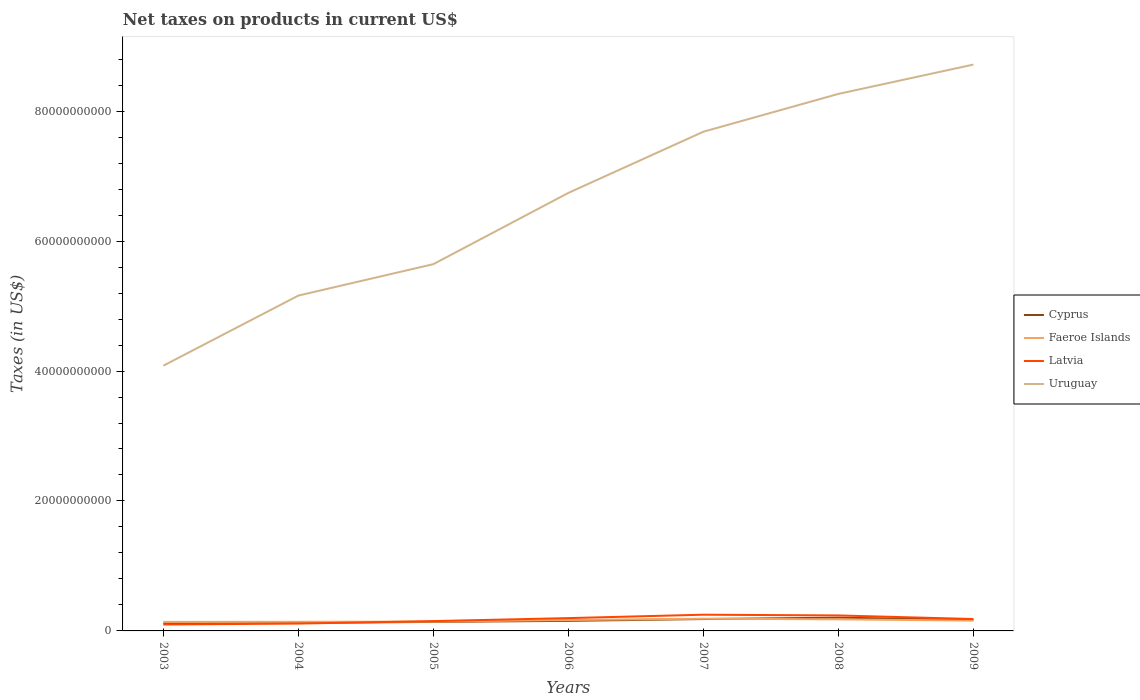Across all years, what is the maximum net taxes on products in Cyprus?
Provide a succinct answer. 1.16e+09. In which year was the net taxes on products in Cyprus maximum?
Give a very brief answer. 2003. What is the total net taxes on products in Latvia in the graph?
Keep it short and to the point. 1.42e+08. What is the difference between the highest and the second highest net taxes on products in Faeroe Islands?
Make the answer very short. 4.94e+08. What is the difference between two consecutive major ticks on the Y-axis?
Ensure brevity in your answer.  2.00e+1. What is the title of the graph?
Make the answer very short. Net taxes on products in current US$. Does "Sweden" appear as one of the legend labels in the graph?
Your answer should be compact. No. What is the label or title of the Y-axis?
Make the answer very short. Taxes (in US$). What is the Taxes (in US$) in Cyprus in 2003?
Make the answer very short. 1.16e+09. What is the Taxes (in US$) in Faeroe Islands in 2003?
Give a very brief answer. 1.39e+09. What is the Taxes (in US$) of Latvia in 2003?
Your response must be concise. 9.88e+08. What is the Taxes (in US$) of Uruguay in 2003?
Provide a short and direct response. 4.08e+1. What is the Taxes (in US$) of Cyprus in 2004?
Provide a short and direct response. 1.25e+09. What is the Taxes (in US$) in Faeroe Islands in 2004?
Your response must be concise. 1.40e+09. What is the Taxes (in US$) of Latvia in 2004?
Give a very brief answer. 1.13e+09. What is the Taxes (in US$) in Uruguay in 2004?
Offer a terse response. 5.16e+1. What is the Taxes (in US$) of Cyprus in 2005?
Keep it short and to the point. 1.39e+09. What is the Taxes (in US$) in Faeroe Islands in 2005?
Offer a terse response. 1.44e+09. What is the Taxes (in US$) in Latvia in 2005?
Ensure brevity in your answer.  1.51e+09. What is the Taxes (in US$) of Uruguay in 2005?
Ensure brevity in your answer.  5.64e+1. What is the Taxes (in US$) of Cyprus in 2006?
Keep it short and to the point. 1.55e+09. What is the Taxes (in US$) in Faeroe Islands in 2006?
Provide a short and direct response. 1.68e+09. What is the Taxes (in US$) of Latvia in 2006?
Ensure brevity in your answer.  1.97e+09. What is the Taxes (in US$) in Uruguay in 2006?
Keep it short and to the point. 6.74e+1. What is the Taxes (in US$) of Cyprus in 2007?
Offer a very short reply. 1.83e+09. What is the Taxes (in US$) in Faeroe Islands in 2007?
Provide a short and direct response. 1.88e+09. What is the Taxes (in US$) of Latvia in 2007?
Keep it short and to the point. 2.50e+09. What is the Taxes (in US$) in Uruguay in 2007?
Keep it short and to the point. 7.68e+1. What is the Taxes (in US$) in Cyprus in 2008?
Your response must be concise. 2.04e+09. What is the Taxes (in US$) in Faeroe Islands in 2008?
Keep it short and to the point. 1.78e+09. What is the Taxes (in US$) of Latvia in 2008?
Your answer should be compact. 2.38e+09. What is the Taxes (in US$) of Uruguay in 2008?
Offer a very short reply. 8.27e+1. What is the Taxes (in US$) of Cyprus in 2009?
Provide a succinct answer. 1.70e+09. What is the Taxes (in US$) in Faeroe Islands in 2009?
Provide a succinct answer. 1.58e+09. What is the Taxes (in US$) of Latvia in 2009?
Your answer should be compact. 1.83e+09. What is the Taxes (in US$) in Uruguay in 2009?
Provide a short and direct response. 8.72e+1. Across all years, what is the maximum Taxes (in US$) of Cyprus?
Your answer should be very brief. 2.04e+09. Across all years, what is the maximum Taxes (in US$) of Faeroe Islands?
Your response must be concise. 1.88e+09. Across all years, what is the maximum Taxes (in US$) in Latvia?
Your answer should be very brief. 2.50e+09. Across all years, what is the maximum Taxes (in US$) in Uruguay?
Your response must be concise. 8.72e+1. Across all years, what is the minimum Taxes (in US$) of Cyprus?
Your answer should be compact. 1.16e+09. Across all years, what is the minimum Taxes (in US$) of Faeroe Islands?
Provide a short and direct response. 1.39e+09. Across all years, what is the minimum Taxes (in US$) of Latvia?
Ensure brevity in your answer.  9.88e+08. Across all years, what is the minimum Taxes (in US$) in Uruguay?
Offer a terse response. 4.08e+1. What is the total Taxes (in US$) of Cyprus in the graph?
Your answer should be very brief. 1.09e+1. What is the total Taxes (in US$) in Faeroe Islands in the graph?
Make the answer very short. 1.12e+1. What is the total Taxes (in US$) in Latvia in the graph?
Provide a short and direct response. 1.23e+1. What is the total Taxes (in US$) in Uruguay in the graph?
Keep it short and to the point. 4.63e+11. What is the difference between the Taxes (in US$) of Cyprus in 2003 and that in 2004?
Offer a very short reply. -8.43e+07. What is the difference between the Taxes (in US$) of Faeroe Islands in 2003 and that in 2004?
Keep it short and to the point. -1.40e+07. What is the difference between the Taxes (in US$) in Latvia in 2003 and that in 2004?
Provide a short and direct response. -1.44e+08. What is the difference between the Taxes (in US$) in Uruguay in 2003 and that in 2004?
Your answer should be compact. -1.08e+1. What is the difference between the Taxes (in US$) in Cyprus in 2003 and that in 2005?
Give a very brief answer. -2.24e+08. What is the difference between the Taxes (in US$) in Faeroe Islands in 2003 and that in 2005?
Ensure brevity in your answer.  -4.80e+07. What is the difference between the Taxes (in US$) of Latvia in 2003 and that in 2005?
Ensure brevity in your answer.  -5.25e+08. What is the difference between the Taxes (in US$) in Uruguay in 2003 and that in 2005?
Ensure brevity in your answer.  -1.56e+1. What is the difference between the Taxes (in US$) of Cyprus in 2003 and that in 2006?
Provide a succinct answer. -3.88e+08. What is the difference between the Taxes (in US$) in Faeroe Islands in 2003 and that in 2006?
Your answer should be very brief. -2.95e+08. What is the difference between the Taxes (in US$) of Latvia in 2003 and that in 2006?
Give a very brief answer. -9.83e+08. What is the difference between the Taxes (in US$) of Uruguay in 2003 and that in 2006?
Your answer should be very brief. -2.66e+1. What is the difference between the Taxes (in US$) of Cyprus in 2003 and that in 2007?
Make the answer very short. -6.66e+08. What is the difference between the Taxes (in US$) in Faeroe Islands in 2003 and that in 2007?
Ensure brevity in your answer.  -4.94e+08. What is the difference between the Taxes (in US$) of Latvia in 2003 and that in 2007?
Ensure brevity in your answer.  -1.51e+09. What is the difference between the Taxes (in US$) in Uruguay in 2003 and that in 2007?
Give a very brief answer. -3.60e+1. What is the difference between the Taxes (in US$) in Cyprus in 2003 and that in 2008?
Provide a short and direct response. -8.80e+08. What is the difference between the Taxes (in US$) of Faeroe Islands in 2003 and that in 2008?
Ensure brevity in your answer.  -3.95e+08. What is the difference between the Taxes (in US$) of Latvia in 2003 and that in 2008?
Make the answer very short. -1.39e+09. What is the difference between the Taxes (in US$) in Uruguay in 2003 and that in 2008?
Provide a succinct answer. -4.18e+1. What is the difference between the Taxes (in US$) in Cyprus in 2003 and that in 2009?
Your answer should be very brief. -5.38e+08. What is the difference between the Taxes (in US$) of Faeroe Islands in 2003 and that in 2009?
Make the answer very short. -1.97e+08. What is the difference between the Taxes (in US$) of Latvia in 2003 and that in 2009?
Make the answer very short. -8.41e+08. What is the difference between the Taxes (in US$) of Uruguay in 2003 and that in 2009?
Your response must be concise. -4.63e+1. What is the difference between the Taxes (in US$) of Cyprus in 2004 and that in 2005?
Ensure brevity in your answer.  -1.40e+08. What is the difference between the Taxes (in US$) of Faeroe Islands in 2004 and that in 2005?
Keep it short and to the point. -3.40e+07. What is the difference between the Taxes (in US$) in Latvia in 2004 and that in 2005?
Your response must be concise. -3.81e+08. What is the difference between the Taxes (in US$) in Uruguay in 2004 and that in 2005?
Give a very brief answer. -4.84e+09. What is the difference between the Taxes (in US$) in Cyprus in 2004 and that in 2006?
Give a very brief answer. -3.03e+08. What is the difference between the Taxes (in US$) of Faeroe Islands in 2004 and that in 2006?
Provide a succinct answer. -2.81e+08. What is the difference between the Taxes (in US$) in Latvia in 2004 and that in 2006?
Provide a short and direct response. -8.39e+08. What is the difference between the Taxes (in US$) of Uruguay in 2004 and that in 2006?
Ensure brevity in your answer.  -1.58e+1. What is the difference between the Taxes (in US$) of Cyprus in 2004 and that in 2007?
Make the answer very short. -5.82e+08. What is the difference between the Taxes (in US$) in Faeroe Islands in 2004 and that in 2007?
Make the answer very short. -4.80e+08. What is the difference between the Taxes (in US$) in Latvia in 2004 and that in 2007?
Your answer should be compact. -1.36e+09. What is the difference between the Taxes (in US$) in Uruguay in 2004 and that in 2007?
Your answer should be compact. -2.52e+1. What is the difference between the Taxes (in US$) in Cyprus in 2004 and that in 2008?
Keep it short and to the point. -7.96e+08. What is the difference between the Taxes (in US$) in Faeroe Islands in 2004 and that in 2008?
Your answer should be compact. -3.81e+08. What is the difference between the Taxes (in US$) of Latvia in 2004 and that in 2008?
Offer a very short reply. -1.25e+09. What is the difference between the Taxes (in US$) of Uruguay in 2004 and that in 2008?
Your response must be concise. -3.10e+1. What is the difference between the Taxes (in US$) in Cyprus in 2004 and that in 2009?
Ensure brevity in your answer.  -4.54e+08. What is the difference between the Taxes (in US$) in Faeroe Islands in 2004 and that in 2009?
Ensure brevity in your answer.  -1.83e+08. What is the difference between the Taxes (in US$) of Latvia in 2004 and that in 2009?
Offer a very short reply. -6.97e+08. What is the difference between the Taxes (in US$) in Uruguay in 2004 and that in 2009?
Your answer should be compact. -3.56e+1. What is the difference between the Taxes (in US$) in Cyprus in 2005 and that in 2006?
Offer a terse response. -1.64e+08. What is the difference between the Taxes (in US$) of Faeroe Islands in 2005 and that in 2006?
Provide a short and direct response. -2.47e+08. What is the difference between the Taxes (in US$) of Latvia in 2005 and that in 2006?
Provide a short and direct response. -4.58e+08. What is the difference between the Taxes (in US$) of Uruguay in 2005 and that in 2006?
Ensure brevity in your answer.  -1.10e+1. What is the difference between the Taxes (in US$) of Cyprus in 2005 and that in 2007?
Keep it short and to the point. -4.42e+08. What is the difference between the Taxes (in US$) in Faeroe Islands in 2005 and that in 2007?
Your answer should be very brief. -4.46e+08. What is the difference between the Taxes (in US$) of Latvia in 2005 and that in 2007?
Provide a short and direct response. -9.83e+08. What is the difference between the Taxes (in US$) in Uruguay in 2005 and that in 2007?
Offer a terse response. -2.04e+1. What is the difference between the Taxes (in US$) of Cyprus in 2005 and that in 2008?
Ensure brevity in your answer.  -6.56e+08. What is the difference between the Taxes (in US$) in Faeroe Islands in 2005 and that in 2008?
Provide a succinct answer. -3.47e+08. What is the difference between the Taxes (in US$) of Latvia in 2005 and that in 2008?
Provide a succinct answer. -8.70e+08. What is the difference between the Taxes (in US$) of Uruguay in 2005 and that in 2008?
Provide a short and direct response. -2.62e+1. What is the difference between the Taxes (in US$) in Cyprus in 2005 and that in 2009?
Give a very brief answer. -3.14e+08. What is the difference between the Taxes (in US$) in Faeroe Islands in 2005 and that in 2009?
Your answer should be compact. -1.49e+08. What is the difference between the Taxes (in US$) of Latvia in 2005 and that in 2009?
Your answer should be compact. -3.16e+08. What is the difference between the Taxes (in US$) of Uruguay in 2005 and that in 2009?
Provide a short and direct response. -3.07e+1. What is the difference between the Taxes (in US$) of Cyprus in 2006 and that in 2007?
Your answer should be very brief. -2.79e+08. What is the difference between the Taxes (in US$) of Faeroe Islands in 2006 and that in 2007?
Your response must be concise. -1.99e+08. What is the difference between the Taxes (in US$) in Latvia in 2006 and that in 2007?
Offer a terse response. -5.24e+08. What is the difference between the Taxes (in US$) of Uruguay in 2006 and that in 2007?
Provide a short and direct response. -9.42e+09. What is the difference between the Taxes (in US$) in Cyprus in 2006 and that in 2008?
Your response must be concise. -4.92e+08. What is the difference between the Taxes (in US$) in Faeroe Islands in 2006 and that in 2008?
Ensure brevity in your answer.  -1.00e+08. What is the difference between the Taxes (in US$) of Latvia in 2006 and that in 2008?
Provide a short and direct response. -4.11e+08. What is the difference between the Taxes (in US$) in Uruguay in 2006 and that in 2008?
Keep it short and to the point. -1.52e+1. What is the difference between the Taxes (in US$) in Cyprus in 2006 and that in 2009?
Keep it short and to the point. -1.51e+08. What is the difference between the Taxes (in US$) of Faeroe Islands in 2006 and that in 2009?
Offer a terse response. 9.80e+07. What is the difference between the Taxes (in US$) of Latvia in 2006 and that in 2009?
Provide a succinct answer. 1.42e+08. What is the difference between the Taxes (in US$) of Uruguay in 2006 and that in 2009?
Offer a terse response. -1.97e+1. What is the difference between the Taxes (in US$) of Cyprus in 2007 and that in 2008?
Provide a succinct answer. -2.14e+08. What is the difference between the Taxes (in US$) of Faeroe Islands in 2007 and that in 2008?
Make the answer very short. 9.90e+07. What is the difference between the Taxes (in US$) of Latvia in 2007 and that in 2008?
Make the answer very short. 1.13e+08. What is the difference between the Taxes (in US$) of Uruguay in 2007 and that in 2008?
Ensure brevity in your answer.  -5.82e+09. What is the difference between the Taxes (in US$) in Cyprus in 2007 and that in 2009?
Your response must be concise. 1.28e+08. What is the difference between the Taxes (in US$) in Faeroe Islands in 2007 and that in 2009?
Provide a short and direct response. 2.97e+08. What is the difference between the Taxes (in US$) of Latvia in 2007 and that in 2009?
Offer a terse response. 6.66e+08. What is the difference between the Taxes (in US$) in Uruguay in 2007 and that in 2009?
Provide a short and direct response. -1.03e+1. What is the difference between the Taxes (in US$) of Cyprus in 2008 and that in 2009?
Provide a short and direct response. 3.42e+08. What is the difference between the Taxes (in US$) in Faeroe Islands in 2008 and that in 2009?
Your answer should be compact. 1.98e+08. What is the difference between the Taxes (in US$) in Latvia in 2008 and that in 2009?
Your response must be concise. 5.53e+08. What is the difference between the Taxes (in US$) in Uruguay in 2008 and that in 2009?
Keep it short and to the point. -4.51e+09. What is the difference between the Taxes (in US$) in Cyprus in 2003 and the Taxes (in US$) in Faeroe Islands in 2004?
Offer a very short reply. -2.40e+08. What is the difference between the Taxes (in US$) in Cyprus in 2003 and the Taxes (in US$) in Latvia in 2004?
Give a very brief answer. 3.05e+07. What is the difference between the Taxes (in US$) of Cyprus in 2003 and the Taxes (in US$) of Uruguay in 2004?
Provide a short and direct response. -5.04e+1. What is the difference between the Taxes (in US$) of Faeroe Islands in 2003 and the Taxes (in US$) of Latvia in 2004?
Offer a terse response. 2.56e+08. What is the difference between the Taxes (in US$) in Faeroe Islands in 2003 and the Taxes (in US$) in Uruguay in 2004?
Keep it short and to the point. -5.02e+1. What is the difference between the Taxes (in US$) in Latvia in 2003 and the Taxes (in US$) in Uruguay in 2004?
Provide a short and direct response. -5.06e+1. What is the difference between the Taxes (in US$) in Cyprus in 2003 and the Taxes (in US$) in Faeroe Islands in 2005?
Your answer should be very brief. -2.74e+08. What is the difference between the Taxes (in US$) of Cyprus in 2003 and the Taxes (in US$) of Latvia in 2005?
Ensure brevity in your answer.  -3.51e+08. What is the difference between the Taxes (in US$) of Cyprus in 2003 and the Taxes (in US$) of Uruguay in 2005?
Keep it short and to the point. -5.53e+1. What is the difference between the Taxes (in US$) in Faeroe Islands in 2003 and the Taxes (in US$) in Latvia in 2005?
Make the answer very short. -1.25e+08. What is the difference between the Taxes (in US$) of Faeroe Islands in 2003 and the Taxes (in US$) of Uruguay in 2005?
Offer a very short reply. -5.51e+1. What is the difference between the Taxes (in US$) of Latvia in 2003 and the Taxes (in US$) of Uruguay in 2005?
Give a very brief answer. -5.55e+1. What is the difference between the Taxes (in US$) in Cyprus in 2003 and the Taxes (in US$) in Faeroe Islands in 2006?
Provide a short and direct response. -5.21e+08. What is the difference between the Taxes (in US$) of Cyprus in 2003 and the Taxes (in US$) of Latvia in 2006?
Make the answer very short. -8.09e+08. What is the difference between the Taxes (in US$) in Cyprus in 2003 and the Taxes (in US$) in Uruguay in 2006?
Your answer should be compact. -6.63e+1. What is the difference between the Taxes (in US$) in Faeroe Islands in 2003 and the Taxes (in US$) in Latvia in 2006?
Provide a short and direct response. -5.83e+08. What is the difference between the Taxes (in US$) in Faeroe Islands in 2003 and the Taxes (in US$) in Uruguay in 2006?
Keep it short and to the point. -6.60e+1. What is the difference between the Taxes (in US$) in Latvia in 2003 and the Taxes (in US$) in Uruguay in 2006?
Provide a short and direct response. -6.64e+1. What is the difference between the Taxes (in US$) in Cyprus in 2003 and the Taxes (in US$) in Faeroe Islands in 2007?
Ensure brevity in your answer.  -7.20e+08. What is the difference between the Taxes (in US$) in Cyprus in 2003 and the Taxes (in US$) in Latvia in 2007?
Keep it short and to the point. -1.33e+09. What is the difference between the Taxes (in US$) in Cyprus in 2003 and the Taxes (in US$) in Uruguay in 2007?
Ensure brevity in your answer.  -7.57e+1. What is the difference between the Taxes (in US$) of Faeroe Islands in 2003 and the Taxes (in US$) of Latvia in 2007?
Ensure brevity in your answer.  -1.11e+09. What is the difference between the Taxes (in US$) of Faeroe Islands in 2003 and the Taxes (in US$) of Uruguay in 2007?
Make the answer very short. -7.54e+1. What is the difference between the Taxes (in US$) in Latvia in 2003 and the Taxes (in US$) in Uruguay in 2007?
Make the answer very short. -7.58e+1. What is the difference between the Taxes (in US$) in Cyprus in 2003 and the Taxes (in US$) in Faeroe Islands in 2008?
Keep it short and to the point. -6.21e+08. What is the difference between the Taxes (in US$) of Cyprus in 2003 and the Taxes (in US$) of Latvia in 2008?
Ensure brevity in your answer.  -1.22e+09. What is the difference between the Taxes (in US$) in Cyprus in 2003 and the Taxes (in US$) in Uruguay in 2008?
Ensure brevity in your answer.  -8.15e+1. What is the difference between the Taxes (in US$) in Faeroe Islands in 2003 and the Taxes (in US$) in Latvia in 2008?
Ensure brevity in your answer.  -9.94e+08. What is the difference between the Taxes (in US$) in Faeroe Islands in 2003 and the Taxes (in US$) in Uruguay in 2008?
Provide a succinct answer. -8.13e+1. What is the difference between the Taxes (in US$) in Latvia in 2003 and the Taxes (in US$) in Uruguay in 2008?
Give a very brief answer. -8.17e+1. What is the difference between the Taxes (in US$) of Cyprus in 2003 and the Taxes (in US$) of Faeroe Islands in 2009?
Your answer should be very brief. -4.23e+08. What is the difference between the Taxes (in US$) in Cyprus in 2003 and the Taxes (in US$) in Latvia in 2009?
Give a very brief answer. -6.67e+08. What is the difference between the Taxes (in US$) in Cyprus in 2003 and the Taxes (in US$) in Uruguay in 2009?
Ensure brevity in your answer.  -8.60e+1. What is the difference between the Taxes (in US$) in Faeroe Islands in 2003 and the Taxes (in US$) in Latvia in 2009?
Offer a terse response. -4.41e+08. What is the difference between the Taxes (in US$) of Faeroe Islands in 2003 and the Taxes (in US$) of Uruguay in 2009?
Your response must be concise. -8.58e+1. What is the difference between the Taxes (in US$) in Latvia in 2003 and the Taxes (in US$) in Uruguay in 2009?
Provide a succinct answer. -8.62e+1. What is the difference between the Taxes (in US$) in Cyprus in 2004 and the Taxes (in US$) in Faeroe Islands in 2005?
Provide a succinct answer. -1.90e+08. What is the difference between the Taxes (in US$) of Cyprus in 2004 and the Taxes (in US$) of Latvia in 2005?
Your answer should be compact. -2.66e+08. What is the difference between the Taxes (in US$) of Cyprus in 2004 and the Taxes (in US$) of Uruguay in 2005?
Provide a short and direct response. -5.52e+1. What is the difference between the Taxes (in US$) of Faeroe Islands in 2004 and the Taxes (in US$) of Latvia in 2005?
Provide a succinct answer. -1.11e+08. What is the difference between the Taxes (in US$) of Faeroe Islands in 2004 and the Taxes (in US$) of Uruguay in 2005?
Give a very brief answer. -5.50e+1. What is the difference between the Taxes (in US$) in Latvia in 2004 and the Taxes (in US$) in Uruguay in 2005?
Your answer should be very brief. -5.53e+1. What is the difference between the Taxes (in US$) in Cyprus in 2004 and the Taxes (in US$) in Faeroe Islands in 2006?
Your answer should be compact. -4.37e+08. What is the difference between the Taxes (in US$) in Cyprus in 2004 and the Taxes (in US$) in Latvia in 2006?
Give a very brief answer. -7.25e+08. What is the difference between the Taxes (in US$) of Cyprus in 2004 and the Taxes (in US$) of Uruguay in 2006?
Offer a terse response. -6.62e+1. What is the difference between the Taxes (in US$) of Faeroe Islands in 2004 and the Taxes (in US$) of Latvia in 2006?
Give a very brief answer. -5.69e+08. What is the difference between the Taxes (in US$) of Faeroe Islands in 2004 and the Taxes (in US$) of Uruguay in 2006?
Ensure brevity in your answer.  -6.60e+1. What is the difference between the Taxes (in US$) in Latvia in 2004 and the Taxes (in US$) in Uruguay in 2006?
Provide a short and direct response. -6.63e+1. What is the difference between the Taxes (in US$) of Cyprus in 2004 and the Taxes (in US$) of Faeroe Islands in 2007?
Offer a terse response. -6.36e+08. What is the difference between the Taxes (in US$) in Cyprus in 2004 and the Taxes (in US$) in Latvia in 2007?
Your answer should be very brief. -1.25e+09. What is the difference between the Taxes (in US$) of Cyprus in 2004 and the Taxes (in US$) of Uruguay in 2007?
Provide a succinct answer. -7.56e+1. What is the difference between the Taxes (in US$) in Faeroe Islands in 2004 and the Taxes (in US$) in Latvia in 2007?
Your answer should be compact. -1.09e+09. What is the difference between the Taxes (in US$) of Faeroe Islands in 2004 and the Taxes (in US$) of Uruguay in 2007?
Ensure brevity in your answer.  -7.54e+1. What is the difference between the Taxes (in US$) in Latvia in 2004 and the Taxes (in US$) in Uruguay in 2007?
Your answer should be very brief. -7.57e+1. What is the difference between the Taxes (in US$) of Cyprus in 2004 and the Taxes (in US$) of Faeroe Islands in 2008?
Offer a terse response. -5.37e+08. What is the difference between the Taxes (in US$) of Cyprus in 2004 and the Taxes (in US$) of Latvia in 2008?
Make the answer very short. -1.14e+09. What is the difference between the Taxes (in US$) in Cyprus in 2004 and the Taxes (in US$) in Uruguay in 2008?
Offer a very short reply. -8.14e+1. What is the difference between the Taxes (in US$) in Faeroe Islands in 2004 and the Taxes (in US$) in Latvia in 2008?
Provide a short and direct response. -9.80e+08. What is the difference between the Taxes (in US$) of Faeroe Islands in 2004 and the Taxes (in US$) of Uruguay in 2008?
Provide a succinct answer. -8.12e+1. What is the difference between the Taxes (in US$) of Latvia in 2004 and the Taxes (in US$) of Uruguay in 2008?
Your answer should be compact. -8.15e+1. What is the difference between the Taxes (in US$) in Cyprus in 2004 and the Taxes (in US$) in Faeroe Islands in 2009?
Make the answer very short. -3.39e+08. What is the difference between the Taxes (in US$) in Cyprus in 2004 and the Taxes (in US$) in Latvia in 2009?
Keep it short and to the point. -5.83e+08. What is the difference between the Taxes (in US$) in Cyprus in 2004 and the Taxes (in US$) in Uruguay in 2009?
Your response must be concise. -8.59e+1. What is the difference between the Taxes (in US$) in Faeroe Islands in 2004 and the Taxes (in US$) in Latvia in 2009?
Provide a succinct answer. -4.27e+08. What is the difference between the Taxes (in US$) of Faeroe Islands in 2004 and the Taxes (in US$) of Uruguay in 2009?
Provide a short and direct response. -8.58e+1. What is the difference between the Taxes (in US$) in Latvia in 2004 and the Taxes (in US$) in Uruguay in 2009?
Your answer should be very brief. -8.60e+1. What is the difference between the Taxes (in US$) of Cyprus in 2005 and the Taxes (in US$) of Faeroe Islands in 2006?
Your response must be concise. -2.97e+08. What is the difference between the Taxes (in US$) in Cyprus in 2005 and the Taxes (in US$) in Latvia in 2006?
Your answer should be very brief. -5.85e+08. What is the difference between the Taxes (in US$) of Cyprus in 2005 and the Taxes (in US$) of Uruguay in 2006?
Provide a short and direct response. -6.60e+1. What is the difference between the Taxes (in US$) of Faeroe Islands in 2005 and the Taxes (in US$) of Latvia in 2006?
Your response must be concise. -5.35e+08. What is the difference between the Taxes (in US$) of Faeroe Islands in 2005 and the Taxes (in US$) of Uruguay in 2006?
Your answer should be very brief. -6.60e+1. What is the difference between the Taxes (in US$) of Latvia in 2005 and the Taxes (in US$) of Uruguay in 2006?
Your answer should be compact. -6.59e+1. What is the difference between the Taxes (in US$) of Cyprus in 2005 and the Taxes (in US$) of Faeroe Islands in 2007?
Keep it short and to the point. -4.96e+08. What is the difference between the Taxes (in US$) in Cyprus in 2005 and the Taxes (in US$) in Latvia in 2007?
Your response must be concise. -1.11e+09. What is the difference between the Taxes (in US$) in Cyprus in 2005 and the Taxes (in US$) in Uruguay in 2007?
Make the answer very short. -7.54e+1. What is the difference between the Taxes (in US$) in Faeroe Islands in 2005 and the Taxes (in US$) in Latvia in 2007?
Your response must be concise. -1.06e+09. What is the difference between the Taxes (in US$) of Faeroe Islands in 2005 and the Taxes (in US$) of Uruguay in 2007?
Give a very brief answer. -7.54e+1. What is the difference between the Taxes (in US$) of Latvia in 2005 and the Taxes (in US$) of Uruguay in 2007?
Ensure brevity in your answer.  -7.53e+1. What is the difference between the Taxes (in US$) of Cyprus in 2005 and the Taxes (in US$) of Faeroe Islands in 2008?
Offer a terse response. -3.97e+08. What is the difference between the Taxes (in US$) of Cyprus in 2005 and the Taxes (in US$) of Latvia in 2008?
Your answer should be very brief. -9.96e+08. What is the difference between the Taxes (in US$) of Cyprus in 2005 and the Taxes (in US$) of Uruguay in 2008?
Keep it short and to the point. -8.13e+1. What is the difference between the Taxes (in US$) in Faeroe Islands in 2005 and the Taxes (in US$) in Latvia in 2008?
Ensure brevity in your answer.  -9.46e+08. What is the difference between the Taxes (in US$) of Faeroe Islands in 2005 and the Taxes (in US$) of Uruguay in 2008?
Your answer should be very brief. -8.12e+1. What is the difference between the Taxes (in US$) in Latvia in 2005 and the Taxes (in US$) in Uruguay in 2008?
Your answer should be very brief. -8.11e+1. What is the difference between the Taxes (in US$) in Cyprus in 2005 and the Taxes (in US$) in Faeroe Islands in 2009?
Your response must be concise. -1.99e+08. What is the difference between the Taxes (in US$) in Cyprus in 2005 and the Taxes (in US$) in Latvia in 2009?
Keep it short and to the point. -4.43e+08. What is the difference between the Taxes (in US$) in Cyprus in 2005 and the Taxes (in US$) in Uruguay in 2009?
Give a very brief answer. -8.58e+1. What is the difference between the Taxes (in US$) of Faeroe Islands in 2005 and the Taxes (in US$) of Latvia in 2009?
Your answer should be very brief. -3.93e+08. What is the difference between the Taxes (in US$) of Faeroe Islands in 2005 and the Taxes (in US$) of Uruguay in 2009?
Your response must be concise. -8.57e+1. What is the difference between the Taxes (in US$) in Latvia in 2005 and the Taxes (in US$) in Uruguay in 2009?
Provide a short and direct response. -8.57e+1. What is the difference between the Taxes (in US$) of Cyprus in 2006 and the Taxes (in US$) of Faeroe Islands in 2007?
Offer a very short reply. -3.32e+08. What is the difference between the Taxes (in US$) in Cyprus in 2006 and the Taxes (in US$) in Latvia in 2007?
Make the answer very short. -9.46e+08. What is the difference between the Taxes (in US$) of Cyprus in 2006 and the Taxes (in US$) of Uruguay in 2007?
Keep it short and to the point. -7.53e+1. What is the difference between the Taxes (in US$) of Faeroe Islands in 2006 and the Taxes (in US$) of Latvia in 2007?
Make the answer very short. -8.12e+08. What is the difference between the Taxes (in US$) in Faeroe Islands in 2006 and the Taxes (in US$) in Uruguay in 2007?
Keep it short and to the point. -7.52e+1. What is the difference between the Taxes (in US$) of Latvia in 2006 and the Taxes (in US$) of Uruguay in 2007?
Keep it short and to the point. -7.49e+1. What is the difference between the Taxes (in US$) in Cyprus in 2006 and the Taxes (in US$) in Faeroe Islands in 2008?
Ensure brevity in your answer.  -2.33e+08. What is the difference between the Taxes (in US$) in Cyprus in 2006 and the Taxes (in US$) in Latvia in 2008?
Ensure brevity in your answer.  -8.32e+08. What is the difference between the Taxes (in US$) in Cyprus in 2006 and the Taxes (in US$) in Uruguay in 2008?
Offer a terse response. -8.11e+1. What is the difference between the Taxes (in US$) in Faeroe Islands in 2006 and the Taxes (in US$) in Latvia in 2008?
Offer a very short reply. -6.99e+08. What is the difference between the Taxes (in US$) of Faeroe Islands in 2006 and the Taxes (in US$) of Uruguay in 2008?
Ensure brevity in your answer.  -8.10e+1. What is the difference between the Taxes (in US$) of Latvia in 2006 and the Taxes (in US$) of Uruguay in 2008?
Give a very brief answer. -8.07e+1. What is the difference between the Taxes (in US$) of Cyprus in 2006 and the Taxes (in US$) of Faeroe Islands in 2009?
Offer a terse response. -3.54e+07. What is the difference between the Taxes (in US$) of Cyprus in 2006 and the Taxes (in US$) of Latvia in 2009?
Make the answer very short. -2.79e+08. What is the difference between the Taxes (in US$) in Cyprus in 2006 and the Taxes (in US$) in Uruguay in 2009?
Keep it short and to the point. -8.56e+1. What is the difference between the Taxes (in US$) of Faeroe Islands in 2006 and the Taxes (in US$) of Latvia in 2009?
Keep it short and to the point. -1.46e+08. What is the difference between the Taxes (in US$) in Faeroe Islands in 2006 and the Taxes (in US$) in Uruguay in 2009?
Your answer should be compact. -8.55e+1. What is the difference between the Taxes (in US$) of Latvia in 2006 and the Taxes (in US$) of Uruguay in 2009?
Give a very brief answer. -8.52e+1. What is the difference between the Taxes (in US$) in Cyprus in 2007 and the Taxes (in US$) in Faeroe Islands in 2008?
Your response must be concise. 4.54e+07. What is the difference between the Taxes (in US$) in Cyprus in 2007 and the Taxes (in US$) in Latvia in 2008?
Make the answer very short. -5.54e+08. What is the difference between the Taxes (in US$) in Cyprus in 2007 and the Taxes (in US$) in Uruguay in 2008?
Ensure brevity in your answer.  -8.08e+1. What is the difference between the Taxes (in US$) of Faeroe Islands in 2007 and the Taxes (in US$) of Latvia in 2008?
Offer a terse response. -5.00e+08. What is the difference between the Taxes (in US$) in Faeroe Islands in 2007 and the Taxes (in US$) in Uruguay in 2008?
Offer a very short reply. -8.08e+1. What is the difference between the Taxes (in US$) of Latvia in 2007 and the Taxes (in US$) of Uruguay in 2008?
Your answer should be compact. -8.02e+1. What is the difference between the Taxes (in US$) in Cyprus in 2007 and the Taxes (in US$) in Faeroe Islands in 2009?
Make the answer very short. 2.43e+08. What is the difference between the Taxes (in US$) in Cyprus in 2007 and the Taxes (in US$) in Latvia in 2009?
Keep it short and to the point. -5.34e+05. What is the difference between the Taxes (in US$) of Cyprus in 2007 and the Taxes (in US$) of Uruguay in 2009?
Your response must be concise. -8.53e+1. What is the difference between the Taxes (in US$) in Faeroe Islands in 2007 and the Taxes (in US$) in Latvia in 2009?
Provide a succinct answer. 5.31e+07. What is the difference between the Taxes (in US$) of Faeroe Islands in 2007 and the Taxes (in US$) of Uruguay in 2009?
Offer a terse response. -8.53e+1. What is the difference between the Taxes (in US$) of Latvia in 2007 and the Taxes (in US$) of Uruguay in 2009?
Keep it short and to the point. -8.47e+1. What is the difference between the Taxes (in US$) in Cyprus in 2008 and the Taxes (in US$) in Faeroe Islands in 2009?
Your answer should be compact. 4.57e+08. What is the difference between the Taxes (in US$) in Cyprus in 2008 and the Taxes (in US$) in Latvia in 2009?
Your answer should be very brief. 2.13e+08. What is the difference between the Taxes (in US$) in Cyprus in 2008 and the Taxes (in US$) in Uruguay in 2009?
Give a very brief answer. -8.51e+1. What is the difference between the Taxes (in US$) in Faeroe Islands in 2008 and the Taxes (in US$) in Latvia in 2009?
Offer a terse response. -4.59e+07. What is the difference between the Taxes (in US$) in Faeroe Islands in 2008 and the Taxes (in US$) in Uruguay in 2009?
Make the answer very short. -8.54e+1. What is the difference between the Taxes (in US$) in Latvia in 2008 and the Taxes (in US$) in Uruguay in 2009?
Make the answer very short. -8.48e+1. What is the average Taxes (in US$) in Cyprus per year?
Give a very brief answer. 1.56e+09. What is the average Taxes (in US$) of Faeroe Islands per year?
Keep it short and to the point. 1.59e+09. What is the average Taxes (in US$) in Latvia per year?
Make the answer very short. 1.76e+09. What is the average Taxes (in US$) of Uruguay per year?
Provide a short and direct response. 6.61e+1. In the year 2003, what is the difference between the Taxes (in US$) of Cyprus and Taxes (in US$) of Faeroe Islands?
Keep it short and to the point. -2.26e+08. In the year 2003, what is the difference between the Taxes (in US$) of Cyprus and Taxes (in US$) of Latvia?
Offer a very short reply. 1.74e+08. In the year 2003, what is the difference between the Taxes (in US$) of Cyprus and Taxes (in US$) of Uruguay?
Your response must be concise. -3.97e+1. In the year 2003, what is the difference between the Taxes (in US$) of Faeroe Islands and Taxes (in US$) of Latvia?
Your response must be concise. 4.00e+08. In the year 2003, what is the difference between the Taxes (in US$) of Faeroe Islands and Taxes (in US$) of Uruguay?
Provide a succinct answer. -3.94e+1. In the year 2003, what is the difference between the Taxes (in US$) of Latvia and Taxes (in US$) of Uruguay?
Provide a succinct answer. -3.98e+1. In the year 2004, what is the difference between the Taxes (in US$) in Cyprus and Taxes (in US$) in Faeroe Islands?
Make the answer very short. -1.56e+08. In the year 2004, what is the difference between the Taxes (in US$) of Cyprus and Taxes (in US$) of Latvia?
Offer a very short reply. 1.15e+08. In the year 2004, what is the difference between the Taxes (in US$) of Cyprus and Taxes (in US$) of Uruguay?
Offer a terse response. -5.04e+1. In the year 2004, what is the difference between the Taxes (in US$) in Faeroe Islands and Taxes (in US$) in Latvia?
Offer a terse response. 2.70e+08. In the year 2004, what is the difference between the Taxes (in US$) in Faeroe Islands and Taxes (in US$) in Uruguay?
Offer a very short reply. -5.02e+1. In the year 2004, what is the difference between the Taxes (in US$) of Latvia and Taxes (in US$) of Uruguay?
Make the answer very short. -5.05e+1. In the year 2005, what is the difference between the Taxes (in US$) of Cyprus and Taxes (in US$) of Faeroe Islands?
Offer a very short reply. -4.99e+07. In the year 2005, what is the difference between the Taxes (in US$) of Cyprus and Taxes (in US$) of Latvia?
Offer a very short reply. -1.26e+08. In the year 2005, what is the difference between the Taxes (in US$) of Cyprus and Taxes (in US$) of Uruguay?
Ensure brevity in your answer.  -5.51e+1. In the year 2005, what is the difference between the Taxes (in US$) in Faeroe Islands and Taxes (in US$) in Latvia?
Your answer should be compact. -7.65e+07. In the year 2005, what is the difference between the Taxes (in US$) of Faeroe Islands and Taxes (in US$) of Uruguay?
Offer a terse response. -5.50e+1. In the year 2005, what is the difference between the Taxes (in US$) in Latvia and Taxes (in US$) in Uruguay?
Offer a terse response. -5.49e+1. In the year 2006, what is the difference between the Taxes (in US$) of Cyprus and Taxes (in US$) of Faeroe Islands?
Provide a short and direct response. -1.33e+08. In the year 2006, what is the difference between the Taxes (in US$) in Cyprus and Taxes (in US$) in Latvia?
Your response must be concise. -4.21e+08. In the year 2006, what is the difference between the Taxes (in US$) of Cyprus and Taxes (in US$) of Uruguay?
Keep it short and to the point. -6.59e+1. In the year 2006, what is the difference between the Taxes (in US$) in Faeroe Islands and Taxes (in US$) in Latvia?
Your answer should be compact. -2.88e+08. In the year 2006, what is the difference between the Taxes (in US$) of Faeroe Islands and Taxes (in US$) of Uruguay?
Make the answer very short. -6.57e+1. In the year 2006, what is the difference between the Taxes (in US$) in Latvia and Taxes (in US$) in Uruguay?
Offer a very short reply. -6.54e+1. In the year 2007, what is the difference between the Taxes (in US$) of Cyprus and Taxes (in US$) of Faeroe Islands?
Your answer should be very brief. -5.36e+07. In the year 2007, what is the difference between the Taxes (in US$) of Cyprus and Taxes (in US$) of Latvia?
Provide a short and direct response. -6.67e+08. In the year 2007, what is the difference between the Taxes (in US$) in Cyprus and Taxes (in US$) in Uruguay?
Offer a terse response. -7.50e+1. In the year 2007, what is the difference between the Taxes (in US$) in Faeroe Islands and Taxes (in US$) in Latvia?
Your response must be concise. -6.13e+08. In the year 2007, what is the difference between the Taxes (in US$) of Faeroe Islands and Taxes (in US$) of Uruguay?
Your answer should be compact. -7.50e+1. In the year 2007, what is the difference between the Taxes (in US$) of Latvia and Taxes (in US$) of Uruguay?
Your answer should be compact. -7.43e+1. In the year 2008, what is the difference between the Taxes (in US$) of Cyprus and Taxes (in US$) of Faeroe Islands?
Ensure brevity in your answer.  2.59e+08. In the year 2008, what is the difference between the Taxes (in US$) of Cyprus and Taxes (in US$) of Latvia?
Keep it short and to the point. -3.40e+08. In the year 2008, what is the difference between the Taxes (in US$) of Cyprus and Taxes (in US$) of Uruguay?
Ensure brevity in your answer.  -8.06e+1. In the year 2008, what is the difference between the Taxes (in US$) of Faeroe Islands and Taxes (in US$) of Latvia?
Ensure brevity in your answer.  -5.99e+08. In the year 2008, what is the difference between the Taxes (in US$) of Faeroe Islands and Taxes (in US$) of Uruguay?
Offer a very short reply. -8.09e+1. In the year 2008, what is the difference between the Taxes (in US$) of Latvia and Taxes (in US$) of Uruguay?
Your answer should be compact. -8.03e+1. In the year 2009, what is the difference between the Taxes (in US$) of Cyprus and Taxes (in US$) of Faeroe Islands?
Ensure brevity in your answer.  1.15e+08. In the year 2009, what is the difference between the Taxes (in US$) in Cyprus and Taxes (in US$) in Latvia?
Your answer should be very brief. -1.29e+08. In the year 2009, what is the difference between the Taxes (in US$) in Cyprus and Taxes (in US$) in Uruguay?
Ensure brevity in your answer.  -8.55e+1. In the year 2009, what is the difference between the Taxes (in US$) of Faeroe Islands and Taxes (in US$) of Latvia?
Offer a terse response. -2.44e+08. In the year 2009, what is the difference between the Taxes (in US$) in Faeroe Islands and Taxes (in US$) in Uruguay?
Your response must be concise. -8.56e+1. In the year 2009, what is the difference between the Taxes (in US$) in Latvia and Taxes (in US$) in Uruguay?
Offer a very short reply. -8.53e+1. What is the ratio of the Taxes (in US$) in Cyprus in 2003 to that in 2004?
Your answer should be very brief. 0.93. What is the ratio of the Taxes (in US$) of Latvia in 2003 to that in 2004?
Make the answer very short. 0.87. What is the ratio of the Taxes (in US$) of Uruguay in 2003 to that in 2004?
Make the answer very short. 0.79. What is the ratio of the Taxes (in US$) of Cyprus in 2003 to that in 2005?
Your answer should be compact. 0.84. What is the ratio of the Taxes (in US$) of Faeroe Islands in 2003 to that in 2005?
Ensure brevity in your answer.  0.97. What is the ratio of the Taxes (in US$) of Latvia in 2003 to that in 2005?
Your response must be concise. 0.65. What is the ratio of the Taxes (in US$) in Uruguay in 2003 to that in 2005?
Give a very brief answer. 0.72. What is the ratio of the Taxes (in US$) of Cyprus in 2003 to that in 2006?
Offer a very short reply. 0.75. What is the ratio of the Taxes (in US$) in Faeroe Islands in 2003 to that in 2006?
Your answer should be very brief. 0.82. What is the ratio of the Taxes (in US$) of Latvia in 2003 to that in 2006?
Your response must be concise. 0.5. What is the ratio of the Taxes (in US$) of Uruguay in 2003 to that in 2006?
Give a very brief answer. 0.61. What is the ratio of the Taxes (in US$) of Cyprus in 2003 to that in 2007?
Offer a very short reply. 0.64. What is the ratio of the Taxes (in US$) of Faeroe Islands in 2003 to that in 2007?
Offer a very short reply. 0.74. What is the ratio of the Taxes (in US$) in Latvia in 2003 to that in 2007?
Your response must be concise. 0.4. What is the ratio of the Taxes (in US$) of Uruguay in 2003 to that in 2007?
Make the answer very short. 0.53. What is the ratio of the Taxes (in US$) in Cyprus in 2003 to that in 2008?
Offer a very short reply. 0.57. What is the ratio of the Taxes (in US$) of Faeroe Islands in 2003 to that in 2008?
Ensure brevity in your answer.  0.78. What is the ratio of the Taxes (in US$) in Latvia in 2003 to that in 2008?
Offer a terse response. 0.41. What is the ratio of the Taxes (in US$) of Uruguay in 2003 to that in 2008?
Give a very brief answer. 0.49. What is the ratio of the Taxes (in US$) in Cyprus in 2003 to that in 2009?
Offer a very short reply. 0.68. What is the ratio of the Taxes (in US$) of Faeroe Islands in 2003 to that in 2009?
Provide a short and direct response. 0.88. What is the ratio of the Taxes (in US$) of Latvia in 2003 to that in 2009?
Give a very brief answer. 0.54. What is the ratio of the Taxes (in US$) of Uruguay in 2003 to that in 2009?
Make the answer very short. 0.47. What is the ratio of the Taxes (in US$) of Cyprus in 2004 to that in 2005?
Provide a short and direct response. 0.9. What is the ratio of the Taxes (in US$) of Faeroe Islands in 2004 to that in 2005?
Give a very brief answer. 0.98. What is the ratio of the Taxes (in US$) of Latvia in 2004 to that in 2005?
Make the answer very short. 0.75. What is the ratio of the Taxes (in US$) in Uruguay in 2004 to that in 2005?
Your answer should be compact. 0.91. What is the ratio of the Taxes (in US$) in Cyprus in 2004 to that in 2006?
Your answer should be compact. 0.8. What is the ratio of the Taxes (in US$) of Faeroe Islands in 2004 to that in 2006?
Your answer should be compact. 0.83. What is the ratio of the Taxes (in US$) of Latvia in 2004 to that in 2006?
Make the answer very short. 0.57. What is the ratio of the Taxes (in US$) of Uruguay in 2004 to that in 2006?
Give a very brief answer. 0.77. What is the ratio of the Taxes (in US$) of Cyprus in 2004 to that in 2007?
Offer a terse response. 0.68. What is the ratio of the Taxes (in US$) of Faeroe Islands in 2004 to that in 2007?
Offer a very short reply. 0.74. What is the ratio of the Taxes (in US$) of Latvia in 2004 to that in 2007?
Your response must be concise. 0.45. What is the ratio of the Taxes (in US$) of Uruguay in 2004 to that in 2007?
Make the answer very short. 0.67. What is the ratio of the Taxes (in US$) of Cyprus in 2004 to that in 2008?
Make the answer very short. 0.61. What is the ratio of the Taxes (in US$) in Faeroe Islands in 2004 to that in 2008?
Offer a terse response. 0.79. What is the ratio of the Taxes (in US$) of Latvia in 2004 to that in 2008?
Provide a succinct answer. 0.47. What is the ratio of the Taxes (in US$) of Uruguay in 2004 to that in 2008?
Make the answer very short. 0.62. What is the ratio of the Taxes (in US$) in Cyprus in 2004 to that in 2009?
Your answer should be very brief. 0.73. What is the ratio of the Taxes (in US$) in Faeroe Islands in 2004 to that in 2009?
Your response must be concise. 0.88. What is the ratio of the Taxes (in US$) of Latvia in 2004 to that in 2009?
Ensure brevity in your answer.  0.62. What is the ratio of the Taxes (in US$) of Uruguay in 2004 to that in 2009?
Your answer should be compact. 0.59. What is the ratio of the Taxes (in US$) in Cyprus in 2005 to that in 2006?
Provide a succinct answer. 0.89. What is the ratio of the Taxes (in US$) of Faeroe Islands in 2005 to that in 2006?
Your answer should be very brief. 0.85. What is the ratio of the Taxes (in US$) of Latvia in 2005 to that in 2006?
Provide a short and direct response. 0.77. What is the ratio of the Taxes (in US$) of Uruguay in 2005 to that in 2006?
Your answer should be very brief. 0.84. What is the ratio of the Taxes (in US$) in Cyprus in 2005 to that in 2007?
Your answer should be very brief. 0.76. What is the ratio of the Taxes (in US$) in Faeroe Islands in 2005 to that in 2007?
Ensure brevity in your answer.  0.76. What is the ratio of the Taxes (in US$) of Latvia in 2005 to that in 2007?
Keep it short and to the point. 0.61. What is the ratio of the Taxes (in US$) of Uruguay in 2005 to that in 2007?
Your response must be concise. 0.73. What is the ratio of the Taxes (in US$) of Cyprus in 2005 to that in 2008?
Ensure brevity in your answer.  0.68. What is the ratio of the Taxes (in US$) in Faeroe Islands in 2005 to that in 2008?
Offer a terse response. 0.81. What is the ratio of the Taxes (in US$) of Latvia in 2005 to that in 2008?
Provide a succinct answer. 0.63. What is the ratio of the Taxes (in US$) of Uruguay in 2005 to that in 2008?
Ensure brevity in your answer.  0.68. What is the ratio of the Taxes (in US$) of Cyprus in 2005 to that in 2009?
Offer a terse response. 0.82. What is the ratio of the Taxes (in US$) in Faeroe Islands in 2005 to that in 2009?
Offer a very short reply. 0.91. What is the ratio of the Taxes (in US$) of Latvia in 2005 to that in 2009?
Offer a terse response. 0.83. What is the ratio of the Taxes (in US$) of Uruguay in 2005 to that in 2009?
Keep it short and to the point. 0.65. What is the ratio of the Taxes (in US$) in Cyprus in 2006 to that in 2007?
Your answer should be very brief. 0.85. What is the ratio of the Taxes (in US$) in Faeroe Islands in 2006 to that in 2007?
Keep it short and to the point. 0.89. What is the ratio of the Taxes (in US$) in Latvia in 2006 to that in 2007?
Offer a very short reply. 0.79. What is the ratio of the Taxes (in US$) of Uruguay in 2006 to that in 2007?
Offer a very short reply. 0.88. What is the ratio of the Taxes (in US$) in Cyprus in 2006 to that in 2008?
Your answer should be compact. 0.76. What is the ratio of the Taxes (in US$) in Faeroe Islands in 2006 to that in 2008?
Ensure brevity in your answer.  0.94. What is the ratio of the Taxes (in US$) in Latvia in 2006 to that in 2008?
Keep it short and to the point. 0.83. What is the ratio of the Taxes (in US$) of Uruguay in 2006 to that in 2008?
Make the answer very short. 0.82. What is the ratio of the Taxes (in US$) of Cyprus in 2006 to that in 2009?
Make the answer very short. 0.91. What is the ratio of the Taxes (in US$) of Faeroe Islands in 2006 to that in 2009?
Provide a short and direct response. 1.06. What is the ratio of the Taxes (in US$) of Latvia in 2006 to that in 2009?
Keep it short and to the point. 1.08. What is the ratio of the Taxes (in US$) in Uruguay in 2006 to that in 2009?
Make the answer very short. 0.77. What is the ratio of the Taxes (in US$) of Cyprus in 2007 to that in 2008?
Provide a succinct answer. 0.9. What is the ratio of the Taxes (in US$) in Faeroe Islands in 2007 to that in 2008?
Provide a succinct answer. 1.06. What is the ratio of the Taxes (in US$) in Latvia in 2007 to that in 2008?
Give a very brief answer. 1.05. What is the ratio of the Taxes (in US$) in Uruguay in 2007 to that in 2008?
Provide a succinct answer. 0.93. What is the ratio of the Taxes (in US$) in Cyprus in 2007 to that in 2009?
Ensure brevity in your answer.  1.08. What is the ratio of the Taxes (in US$) of Faeroe Islands in 2007 to that in 2009?
Provide a short and direct response. 1.19. What is the ratio of the Taxes (in US$) in Latvia in 2007 to that in 2009?
Offer a very short reply. 1.36. What is the ratio of the Taxes (in US$) in Uruguay in 2007 to that in 2009?
Give a very brief answer. 0.88. What is the ratio of the Taxes (in US$) of Cyprus in 2008 to that in 2009?
Your response must be concise. 1.2. What is the ratio of the Taxes (in US$) in Faeroe Islands in 2008 to that in 2009?
Offer a terse response. 1.12. What is the ratio of the Taxes (in US$) of Latvia in 2008 to that in 2009?
Offer a terse response. 1.3. What is the ratio of the Taxes (in US$) in Uruguay in 2008 to that in 2009?
Offer a very short reply. 0.95. What is the difference between the highest and the second highest Taxes (in US$) in Cyprus?
Offer a terse response. 2.14e+08. What is the difference between the highest and the second highest Taxes (in US$) in Faeroe Islands?
Your response must be concise. 9.90e+07. What is the difference between the highest and the second highest Taxes (in US$) of Latvia?
Make the answer very short. 1.13e+08. What is the difference between the highest and the second highest Taxes (in US$) of Uruguay?
Your response must be concise. 4.51e+09. What is the difference between the highest and the lowest Taxes (in US$) in Cyprus?
Your answer should be very brief. 8.80e+08. What is the difference between the highest and the lowest Taxes (in US$) in Faeroe Islands?
Keep it short and to the point. 4.94e+08. What is the difference between the highest and the lowest Taxes (in US$) in Latvia?
Keep it short and to the point. 1.51e+09. What is the difference between the highest and the lowest Taxes (in US$) of Uruguay?
Ensure brevity in your answer.  4.63e+1. 